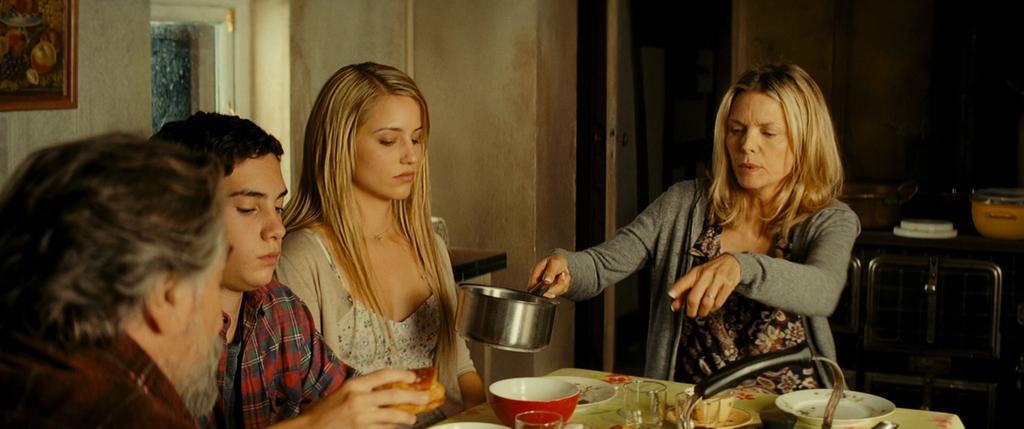Can you describe this image briefly? In this picture we can see four people sitting on chairs and in front of them on the table we can see plates, glasses, cup and saucer, bowl and in the background we can see a frame on the wall, window, door and some objects. 